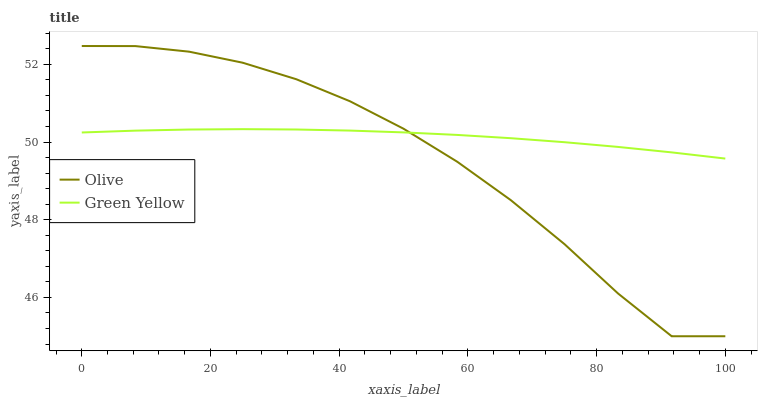Does Olive have the minimum area under the curve?
Answer yes or no. Yes. Does Green Yellow have the maximum area under the curve?
Answer yes or no. Yes. Does Green Yellow have the minimum area under the curve?
Answer yes or no. No. Is Green Yellow the smoothest?
Answer yes or no. Yes. Is Olive the roughest?
Answer yes or no. Yes. Is Green Yellow the roughest?
Answer yes or no. No. Does Olive have the lowest value?
Answer yes or no. Yes. Does Green Yellow have the lowest value?
Answer yes or no. No. Does Olive have the highest value?
Answer yes or no. Yes. Does Green Yellow have the highest value?
Answer yes or no. No. Does Olive intersect Green Yellow?
Answer yes or no. Yes. Is Olive less than Green Yellow?
Answer yes or no. No. Is Olive greater than Green Yellow?
Answer yes or no. No. 